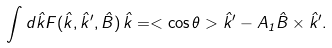Convert formula to latex. <formula><loc_0><loc_0><loc_500><loc_500>\int d \hat { k } F ( \hat { k } , \hat { k } ^ { \prime } , \hat { B } ) \, \hat { k } = < \cos \theta > \hat { k } ^ { \prime } - A _ { 1 } \hat { B } \times \hat { k } ^ { \prime } .</formula> 